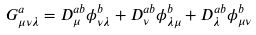<formula> <loc_0><loc_0><loc_500><loc_500>G _ { \mu \nu \lambda } ^ { a } = D _ { \mu } ^ { a b } \phi _ { \nu \lambda } ^ { b } + D _ { \nu } ^ { a b } \phi _ { \lambda \mu } ^ { b } + D _ { \lambda } ^ { a b } \phi _ { \mu \nu } ^ { b }</formula> 